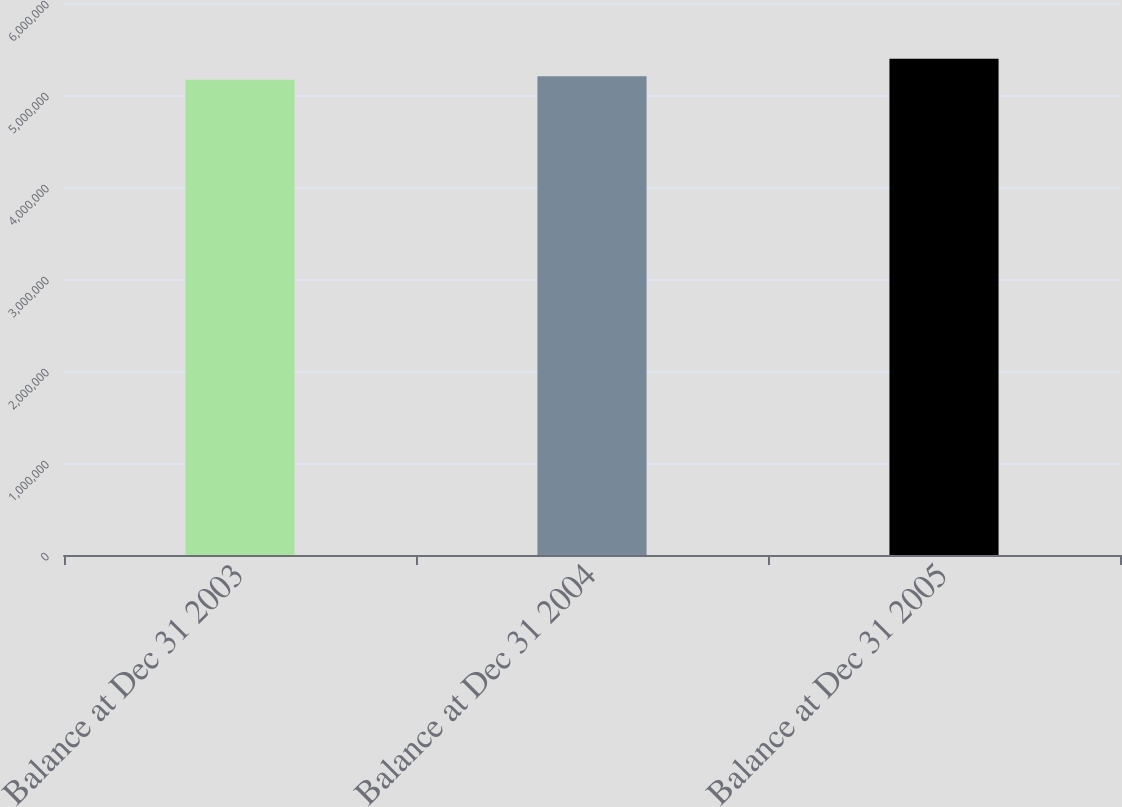Convert chart. <chart><loc_0><loc_0><loc_500><loc_500><bar_chart><fcel>Balance at Dec 31 2003<fcel>Balance at Dec 31 2004<fcel>Balance at Dec 31 2005<nl><fcel>5.16644e+06<fcel>5.20292e+06<fcel>5.39526e+06<nl></chart> 